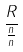Convert formula to latex. <formula><loc_0><loc_0><loc_500><loc_500>\frac { R } { \frac { n } { n } }</formula> 